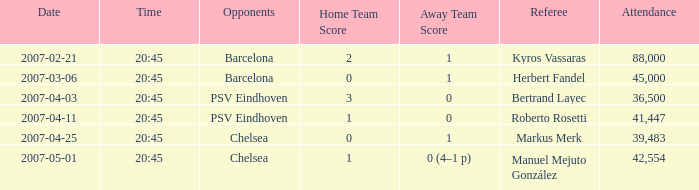How did the game that kicked off at 20:45 on the 6th of march, 2007, end in terms of score? 0–1. 